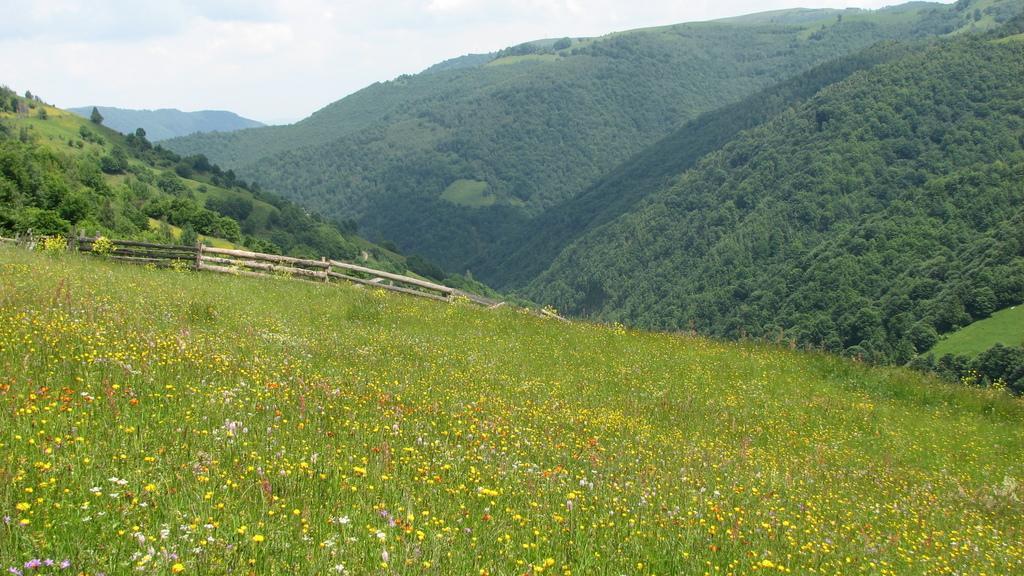In one or two sentences, can you explain what this image depicts? In this image we can see a flower garden. There is a fencing in the image. There are many trees in the image. There are many forest mountains in the image. There is a cloudy sky in the image. 